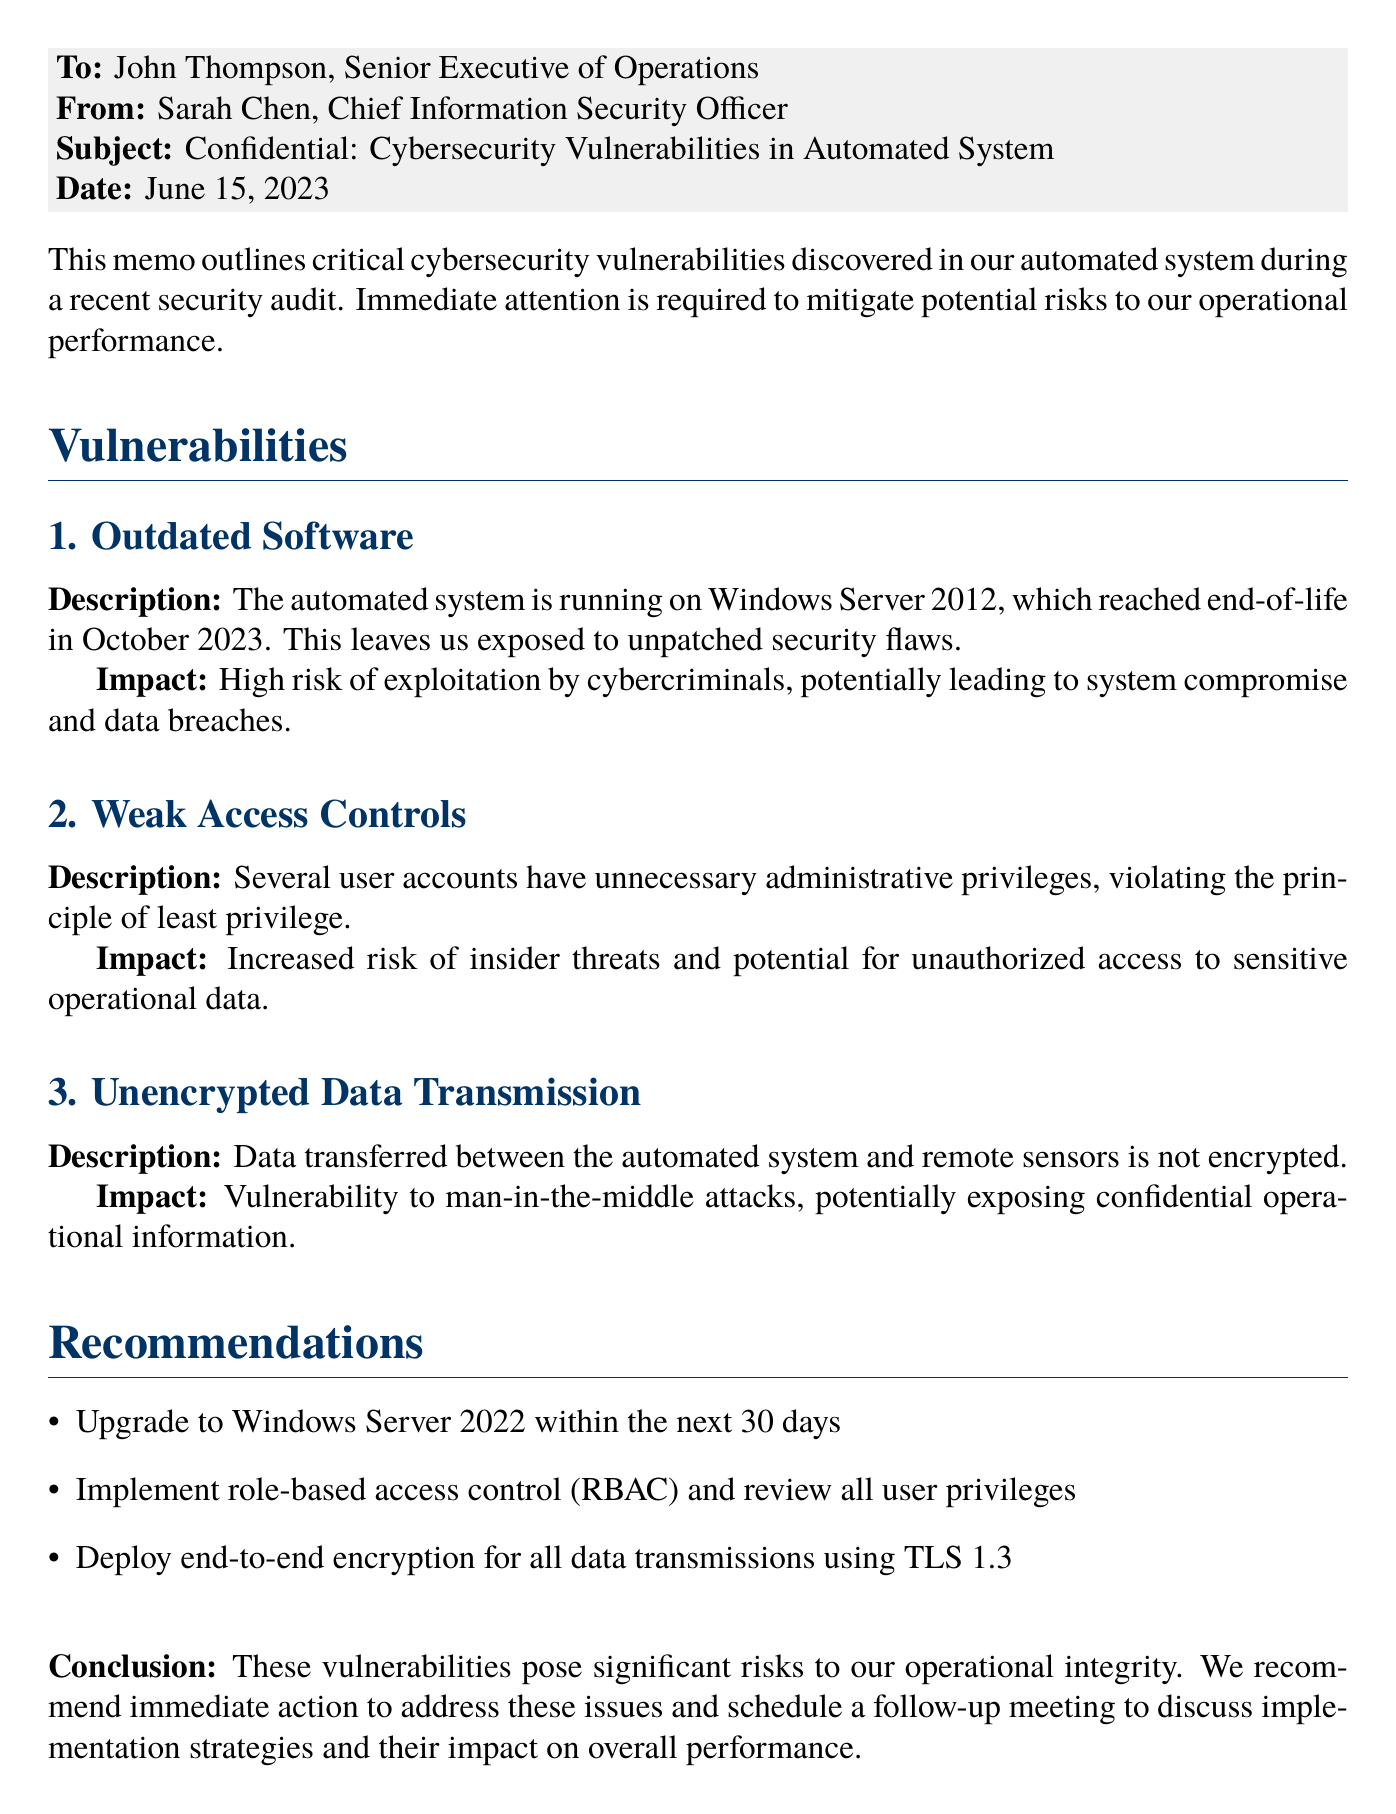What is the date of the memo? The date mentioned in the memo is when the document was created, which is June 15, 2023.
Answer: June 15, 2023 Who is the Chief Information Security Officer? The memo identifies the sender, Sarah Chen, as the Chief Information Security Officer of the company.
Answer: Sarah Chen What is the first identified vulnerability? The first vulnerability outlined in the memo pertains to software that is outdated, specifically the operating system being used.
Answer: Outdated Software What software version is mentioned? The document specifically states that the automated system is running on Windows Server 2012.
Answer: Windows Server 2012 What is a recommended action regarding user privileges? The memo recommends implementing role-based access control (RBAC) to review all user privileges.
Answer: Implement RBAC What is the deadline for upgrading the software? According to the recommendations, the upgrade to Windows Server 2022 should occur within 30 days of the memo's date.
Answer: 30 days What type of data vulnerability is described during transmission? The memo states that data transmission between the automated system and remote sensors is unencrypted.
Answer: Unencrypted Data Transmission What is the potential consequence of weak access controls? The document indicates that weak access controls increase the risk of insider threats and unauthorized access.
Answer: Insider threats What is the impact of running outdated software? The memo highlights a high risk of exploitation by cybercriminals due to running outdated software.
Answer: High risk of exploitation 